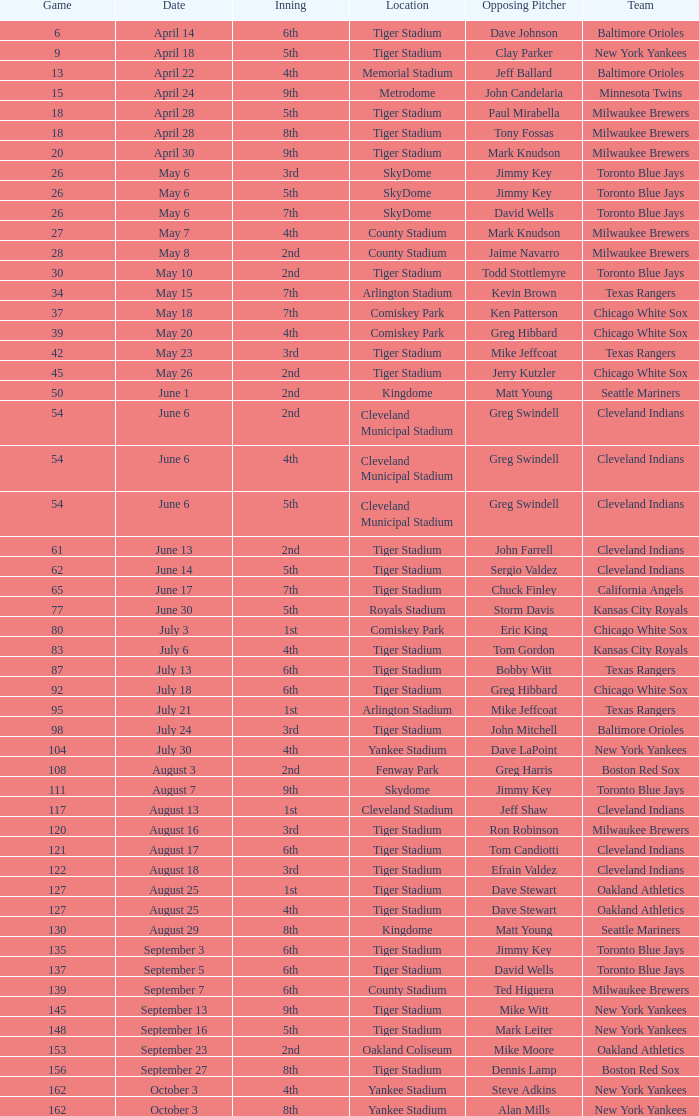What date was the game at Comiskey Park and had a 4th Inning? May 20. 